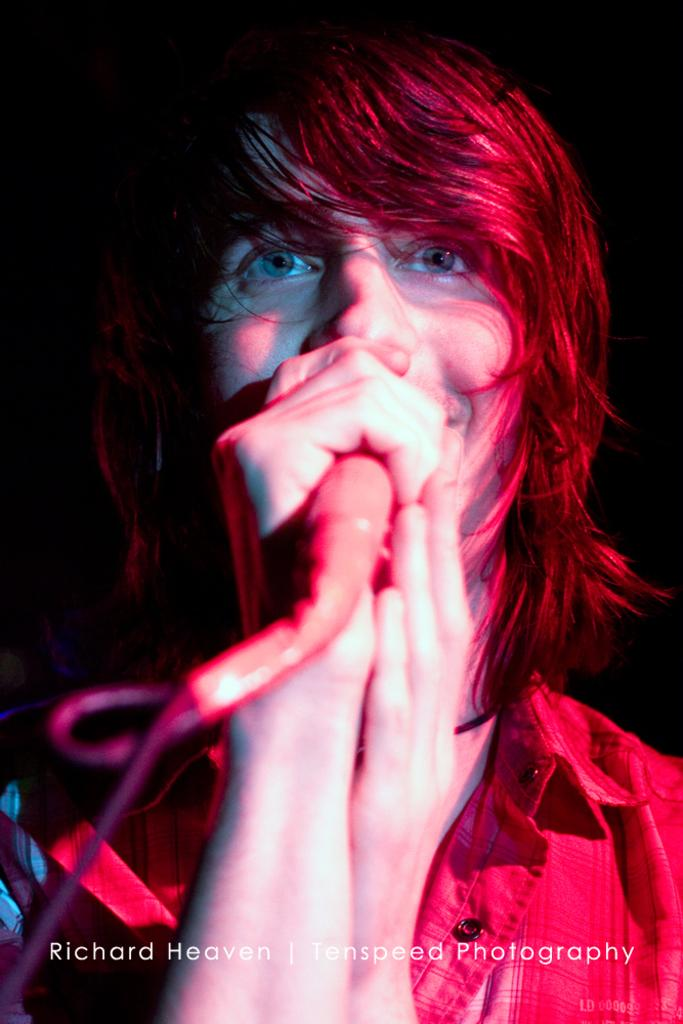What is the main subject of the picture? The main subject of the picture is a man. What is the man holding in the picture? The man is holding a microphone. What is the man doing in the picture? The man is singing. Can you see any springs in the picture? There are no springs visible in the picture. What type of letters is the man holding in the picture? The man is not holding any letters in the picture; he is holding a microphone. 